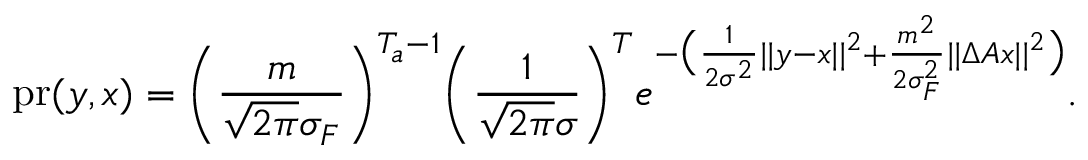Convert formula to latex. <formula><loc_0><loc_0><loc_500><loc_500>p r ( y , x ) = \left ( \frac { m } { \sqrt { 2 \pi } \sigma _ { F } } \right ) ^ { T _ { a } - 1 } \left ( \frac { 1 } { \sqrt { 2 \pi } \sigma } \right ) ^ { T } e ^ { - \left ( \frac { 1 } { 2 \sigma ^ { 2 } } | | y - x | | ^ { 2 } + \frac { m ^ { 2 } } { 2 \sigma _ { F } ^ { 2 } } | | \Delta A x | | ^ { 2 } \right ) } .</formula> 